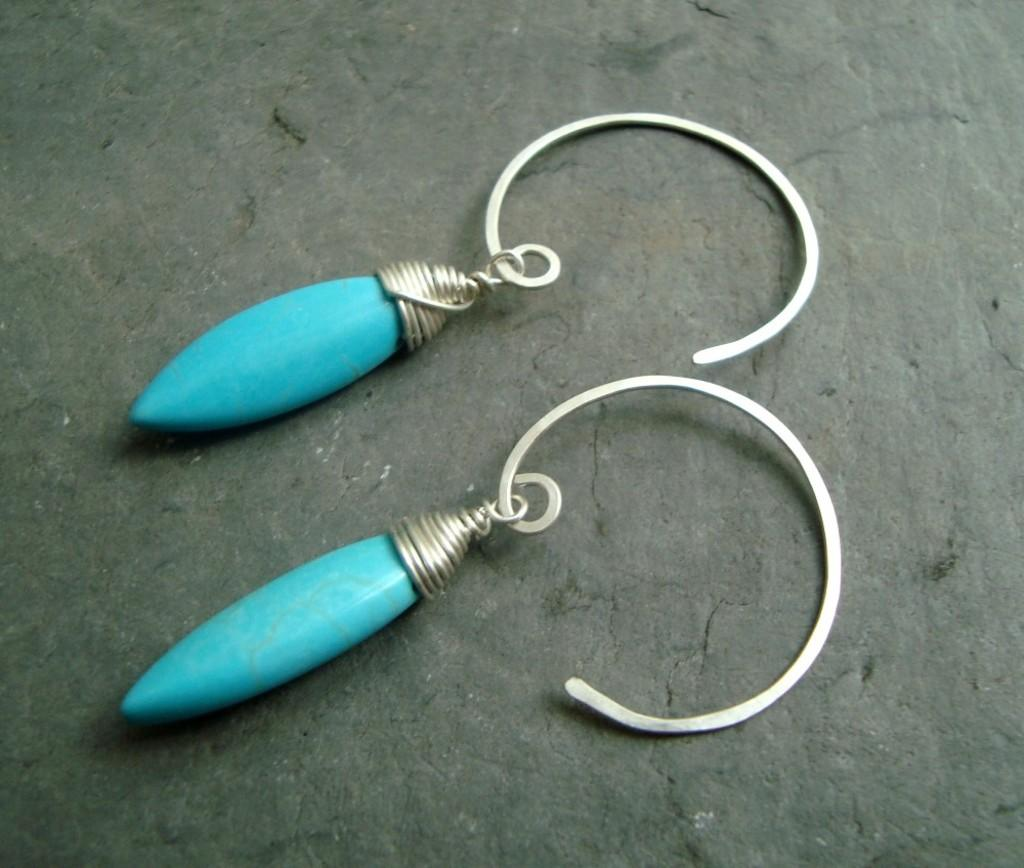What type of accessory is featured in the image? There are two earrings in the image. What color are the earrings? The earrings are blue in color. What type of camera is visible in the image? There is no camera present in the image; it only features two blue earrings. How many wheels can be seen in the image? There are no wheels present in the image; it only features two blue earrings. 